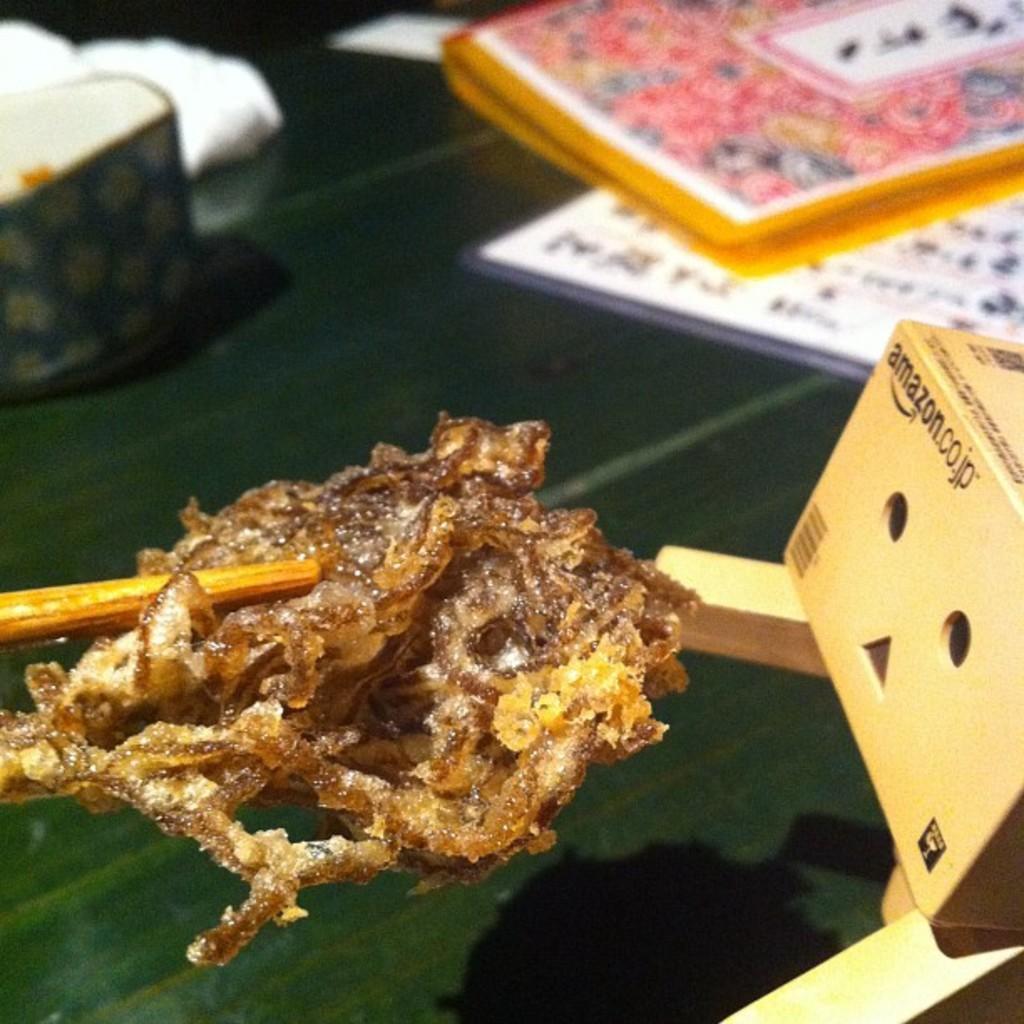Can you describe this image briefly? In this image I can see a food item with a chopstick. There is a cardboard box and in the background there are some objects. 